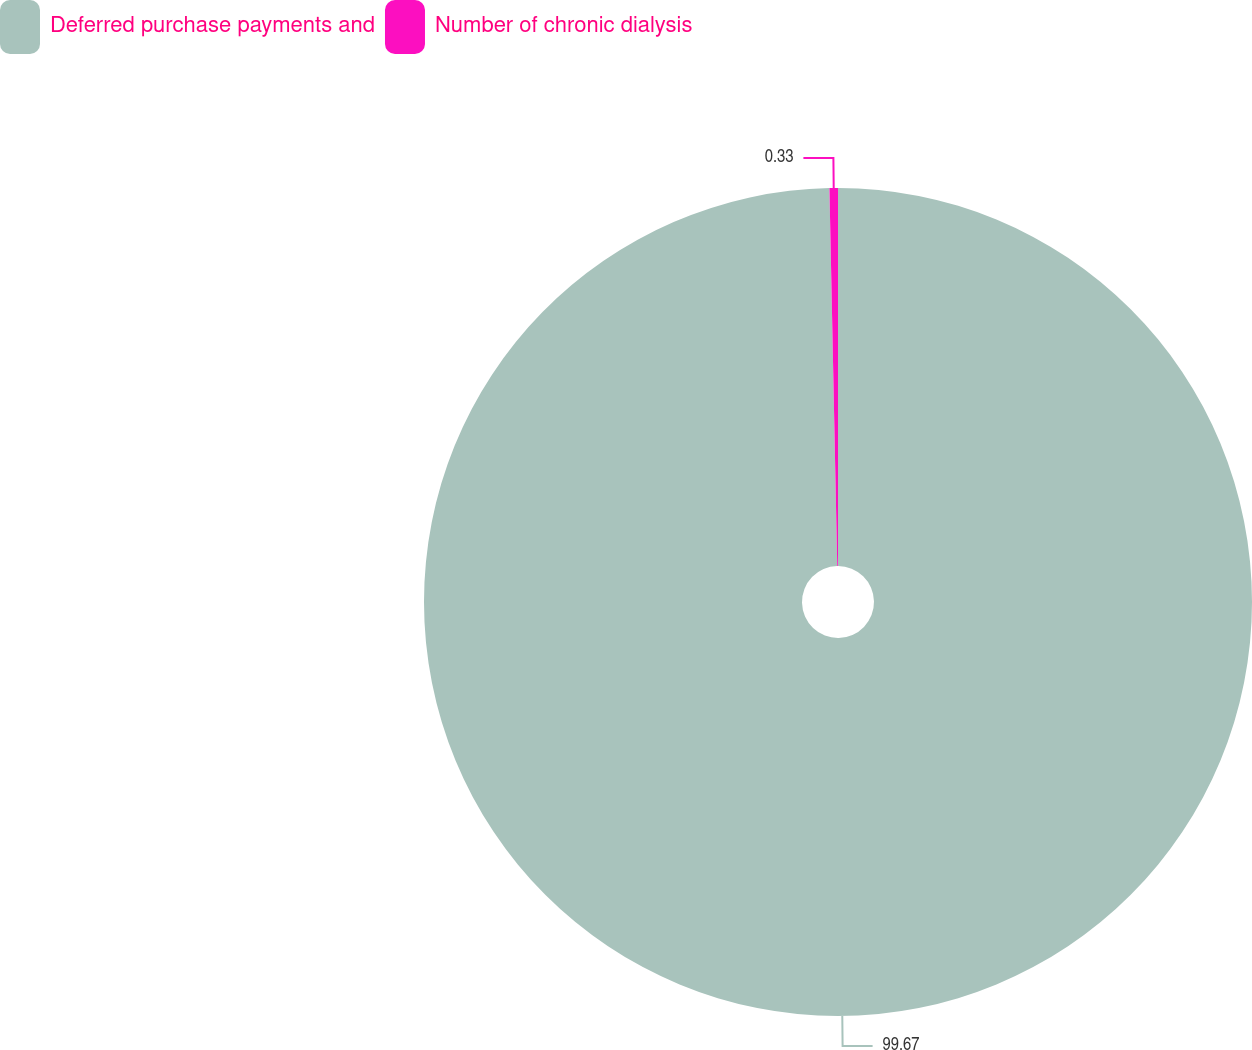Convert chart to OTSL. <chart><loc_0><loc_0><loc_500><loc_500><pie_chart><fcel>Deferred purchase payments and<fcel>Number of chronic dialysis<nl><fcel>99.67%<fcel>0.33%<nl></chart> 